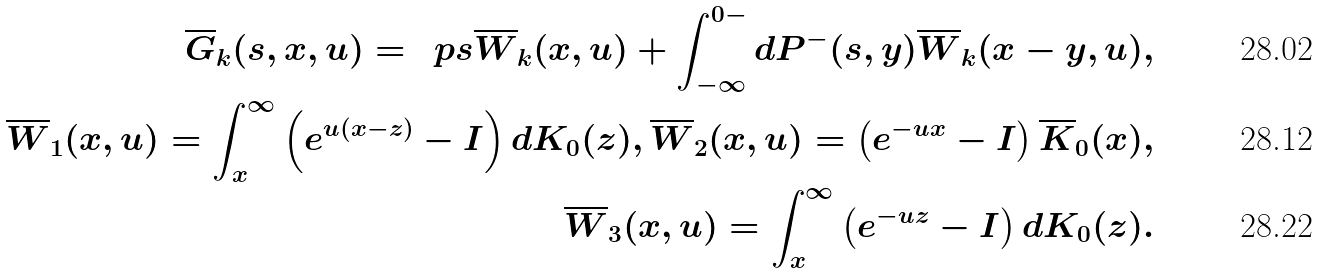Convert formula to latex. <formula><loc_0><loc_0><loc_500><loc_500>\overline { G } _ { k } ( s , x , u ) = \, \ p s \overline { W } _ { k } ( x , u ) + \int _ { - \infty } ^ { 0 - } d P ^ { - } ( s , y ) \overline { W } _ { k } ( x - y , u ) , \\ \overline { W } _ { 1 } ( x , u ) = \int _ { x } ^ { \infty } \left ( e ^ { u ( x - z ) } - I \right ) d K _ { 0 } ( z ) , \overline { W } _ { 2 } ( x , u ) = \left ( e ^ { - u x } - I \right ) \overline { K } _ { 0 } ( x ) , \\ \overline { W } _ { 3 } ( x , u ) = \int _ { x } ^ { \infty } \left ( e ^ { - u z } - I \right ) d K _ { 0 } ( z ) .</formula> 